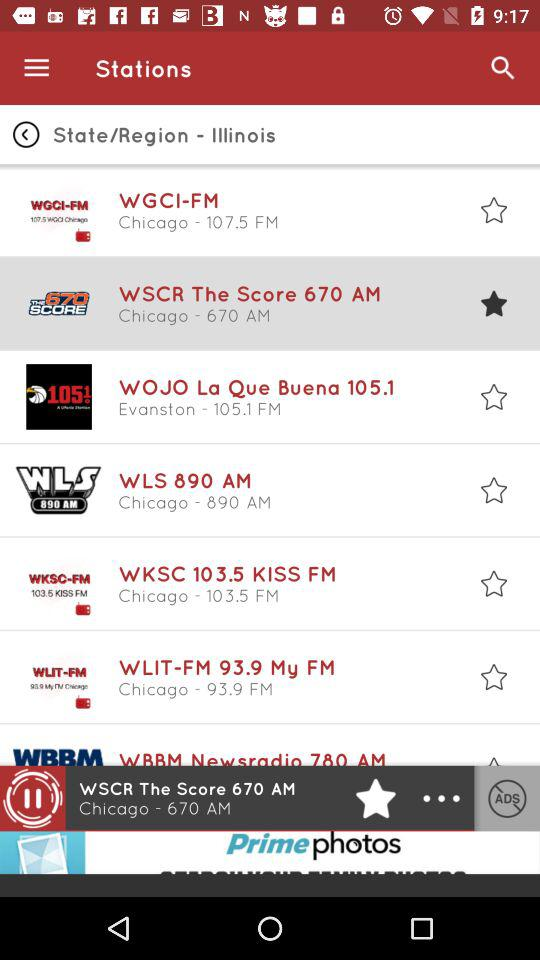What are the FM stations available on the list? The available FM stations are "WGCI-FM", "WSCR The Score 670 AM", "WOJO La Que Buena 105.1", "WLS 890 AM", "WKSC 103.5 KISS FM", "WLIT-FM 93.9 My FM" and "WBBM Newsradio 780 AM". 